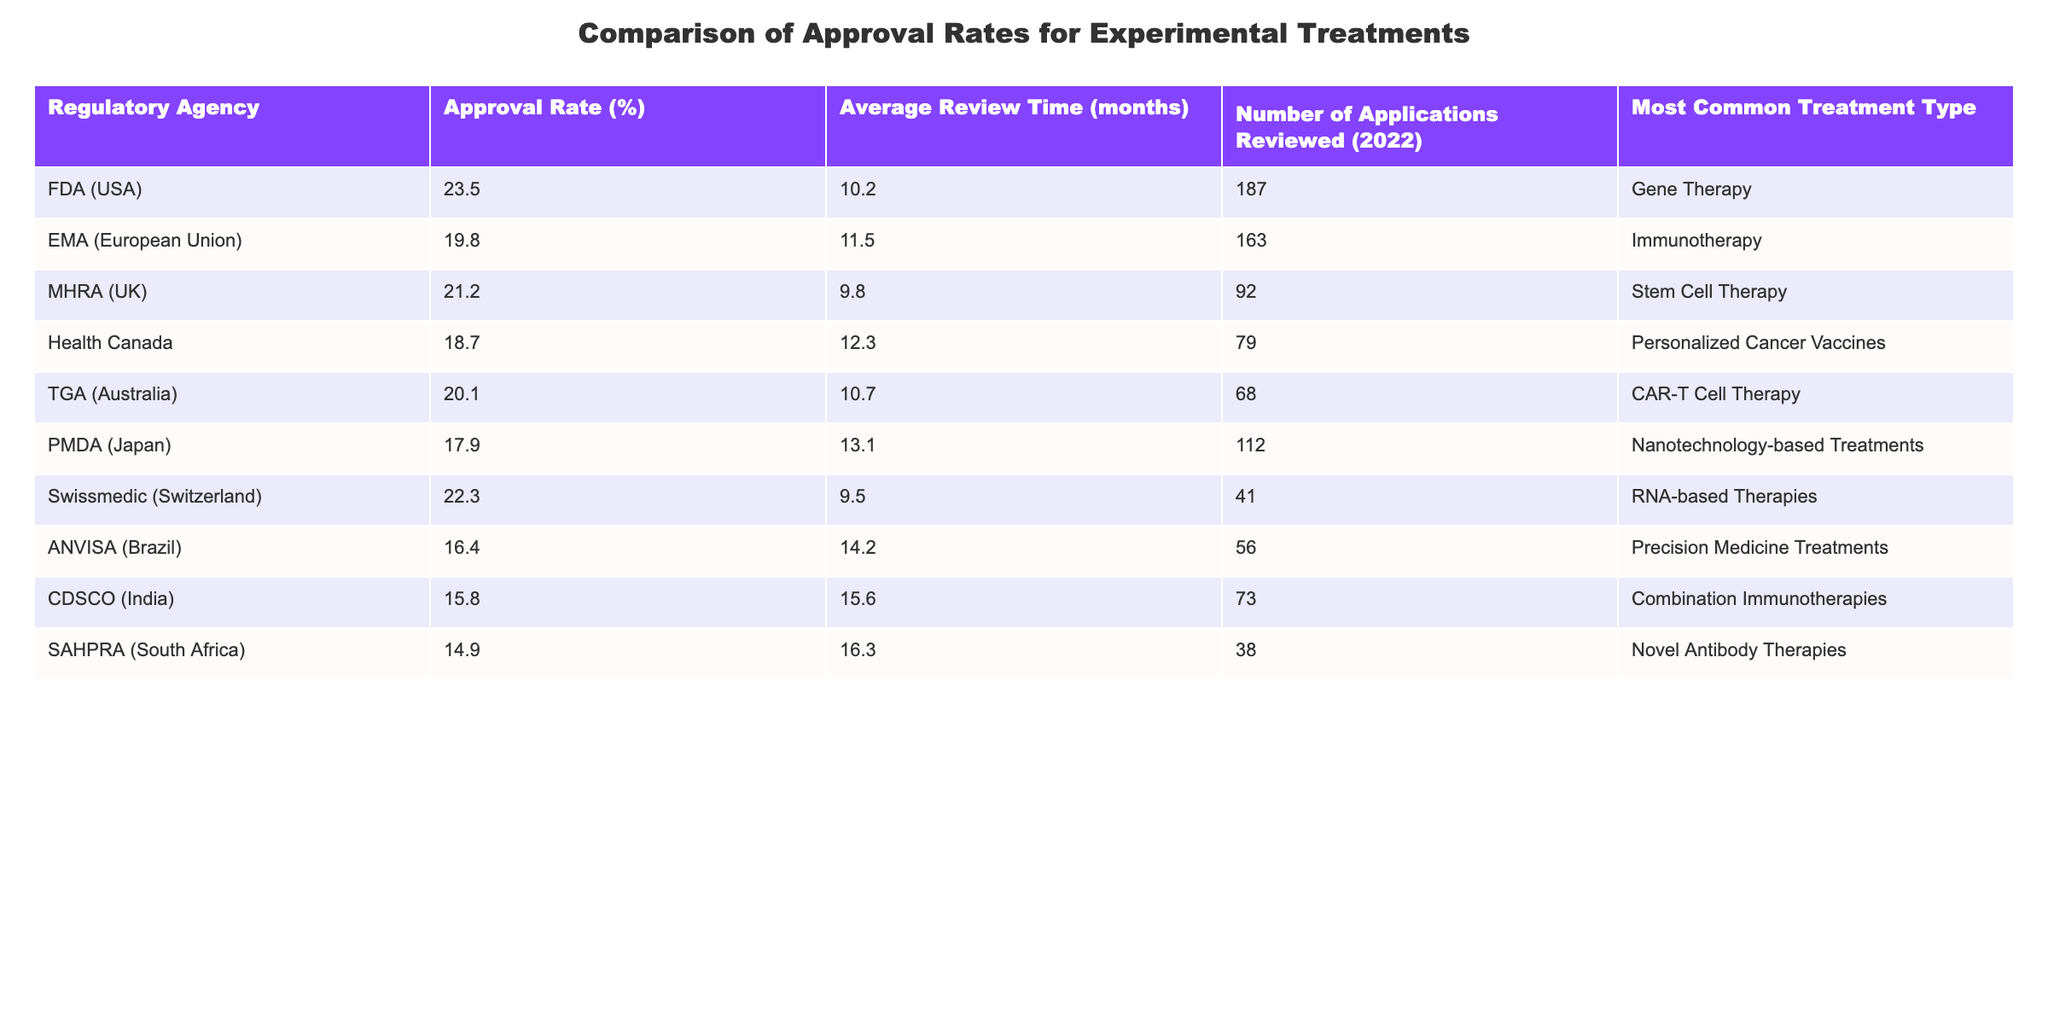What is the approval rate for Health Canada? The table indicates that the approval rate for Health Canada is 18.7%.
Answer: 18.7% Which regulatory agency has the highest approval rate? By comparing the approval rates listed, it is clear that the FDA (USA) has the highest approval rate at 23.5%.
Answer: FDA (USA) What is the average review time for PMDA? The average review time for PMDA (Japan) is 13.1 months, as shown in the table.
Answer: 13.1 months Which treatment type is the most common among the applications reviewed by the EMA? According to the table, the most common treatment type reviewed by the EMA (European Union) is Immunotherapy.
Answer: Immunotherapy What is the difference in approval rates between the highest (FDA) and the lowest (ANVISA) regulatory agencies? The approval rate for FDA is 23.5% and for ANVISA it is 16.4%. The difference is 23.5% - 16.4% = 7.1%.
Answer: 7.1% How many total applications were reviewed by all the regulatory agencies listed? We can sum the number of applications reviewed: 187 + 163 + 92 + 79 + 68 + 112 + 41 + 56 + 73 + 38 =  900.
Answer: 900 Which regulatory agency had the shortest average review time, and what is that time? Examining the average review times in the table, MHRA (UK) has the shortest review time at 9.8 months.
Answer: MHRA (UK), 9.8 months Is the approval rate for TGA higher than that for CDSCO? The approval rate for TGA (Australia) is 20.1%, while CDSCO (India) has an approval rate of 15.8%. Therefore, TGA's approval rate is higher.
Answer: Yes What is the average approval rate across the listed regulatory agencies? To find the average, we add all approval rates and divide by the number of agencies: (23.5 + 19.8 + 21.2 + 18.7 + 20.1 + 17.9 + 22.3 + 16.4 + 15.8 + 14.9)/10 = 18.96%.
Answer: 18.96% Which treatment type has the highest frequency across the agencies listed in the table? By reviewing the 'Most Common Treatment Type' column, we see various types but no single type appears more than once, indicating a variety of specialties.
Answer: None (varied types) 